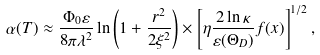<formula> <loc_0><loc_0><loc_500><loc_500>\alpha ( T ) \approx \frac { \Phi _ { 0 } \varepsilon } { 8 \pi \lambda ^ { 2 } } \ln \left ( 1 + \frac { r ^ { 2 } } { 2 \xi ^ { 2 } } \right ) \times \left [ \eta \frac { 2 \ln \kappa } { \varepsilon ( \Theta _ { D } ) } f ( x ) \right ] ^ { 1 / 2 } ,</formula> 